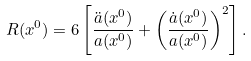<formula> <loc_0><loc_0><loc_500><loc_500>R ( x ^ { 0 } ) & = 6 \left [ \frac { \ddot { a } ( x ^ { 0 } ) } { a ( x ^ { 0 } ) } + \left ( \frac { \dot { a } ( x ^ { 0 } ) } { a ( x ^ { 0 } ) } \right ) ^ { 2 } \right ] .</formula> 